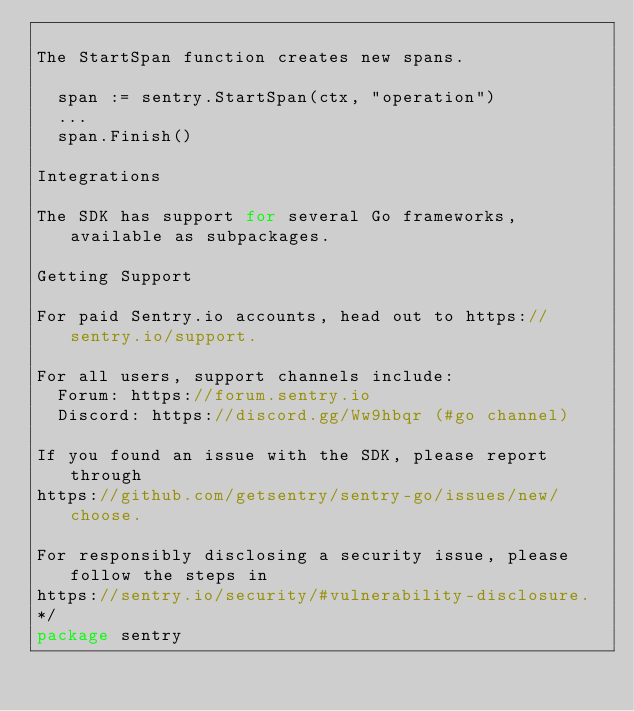Convert code to text. <code><loc_0><loc_0><loc_500><loc_500><_Go_>
The StartSpan function creates new spans.

	span := sentry.StartSpan(ctx, "operation")
	...
	span.Finish()

Integrations

The SDK has support for several Go frameworks, available as subpackages.

Getting Support

For paid Sentry.io accounts, head out to https://sentry.io/support.

For all users, support channels include:
	Forum: https://forum.sentry.io
	Discord: https://discord.gg/Ww9hbqr (#go channel)

If you found an issue with the SDK, please report through
https://github.com/getsentry/sentry-go/issues/new/choose.

For responsibly disclosing a security issue, please follow the steps in
https://sentry.io/security/#vulnerability-disclosure.
*/
package sentry
</code> 